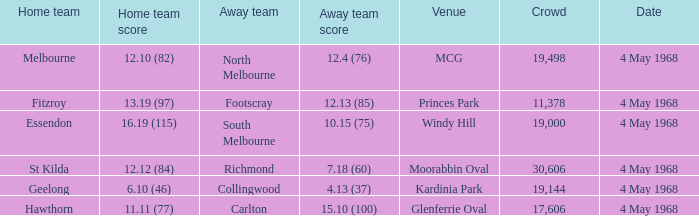What was the magnitude of the crowd for the team that scored 19144.0. 